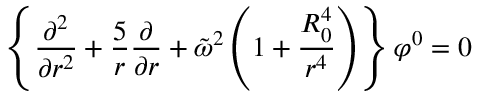Convert formula to latex. <formula><loc_0><loc_0><loc_500><loc_500>\left \{ { \frac { \partial ^ { 2 } } { \partial r ^ { 2 } } } + { \frac { 5 } { r } } { \frac { \partial } { \partial r } } + \tilde { \omega } ^ { 2 } \left ( 1 + { \frac { R _ { 0 } ^ { 4 } } { r ^ { 4 } } } \right ) \right \} \varphi ^ { 0 } = 0</formula> 